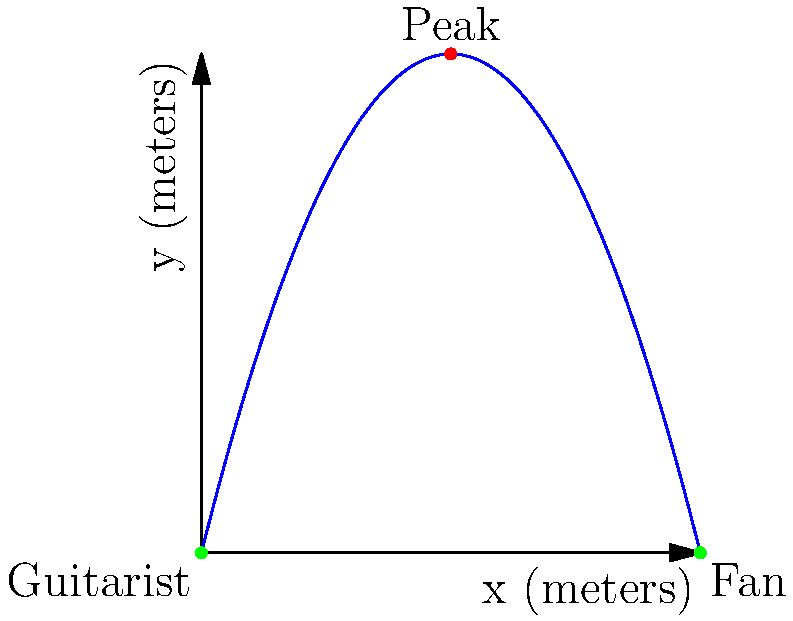At a farewell concert for a beloved Toronto indie band, the guitarist throws their pick into the crowd. The trajectory of the pick can be modeled by the function $f(x)=-0.5x^2+4x$, where $x$ is the horizontal distance from the guitarist (in meters) and $f(x)$ is the height of the pick (in meters). If a fan catches the pick 8 meters away from the guitarist, what is the total distance traveled by the pick? To find the total distance traveled by the pick, we need to calculate the arc length of the parabola from x = 0 to x = 8. Here's how we do it:

1) The formula for arc length is:
   $$L = \int_a^b \sqrt{1 + [f'(x)]^2} dx$$

2) First, we need to find $f'(x)$:
   $f(x) = -0.5x^2 + 4x$
   $f'(x) = -x + 4$

3) Now we can set up our integral:
   $$L = \int_0^8 \sqrt{1 + (-x + 4)^2} dx$$

4) This integral is complex to solve by hand, so we would typically use numerical integration methods or a calculator.

5) Using a calculator or computer algebra system, we find:
   $$L \approx 8.944 \text{ meters}$$

This result represents the total distance traveled by the pick along its parabolic path from the guitarist to the fan.
Answer: 8.944 meters 